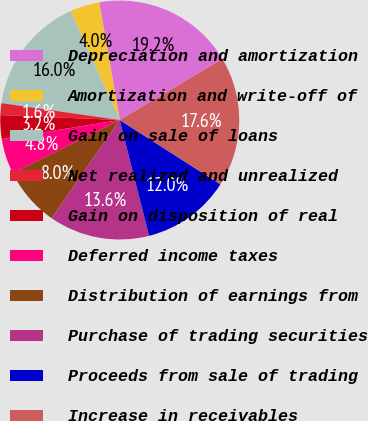Convert chart to OTSL. <chart><loc_0><loc_0><loc_500><loc_500><pie_chart><fcel>Depreciation and amortization<fcel>Amortization and write-off of<fcel>Gain on sale of loans<fcel>Net realized and unrealized<fcel>Gain on disposition of real<fcel>Deferred income taxes<fcel>Distribution of earnings from<fcel>Purchase of trading securities<fcel>Proceeds from sale of trading<fcel>Increase in receivables<nl><fcel>19.2%<fcel>4.0%<fcel>16.0%<fcel>1.6%<fcel>3.2%<fcel>4.8%<fcel>8.0%<fcel>13.6%<fcel>12.0%<fcel>17.6%<nl></chart> 